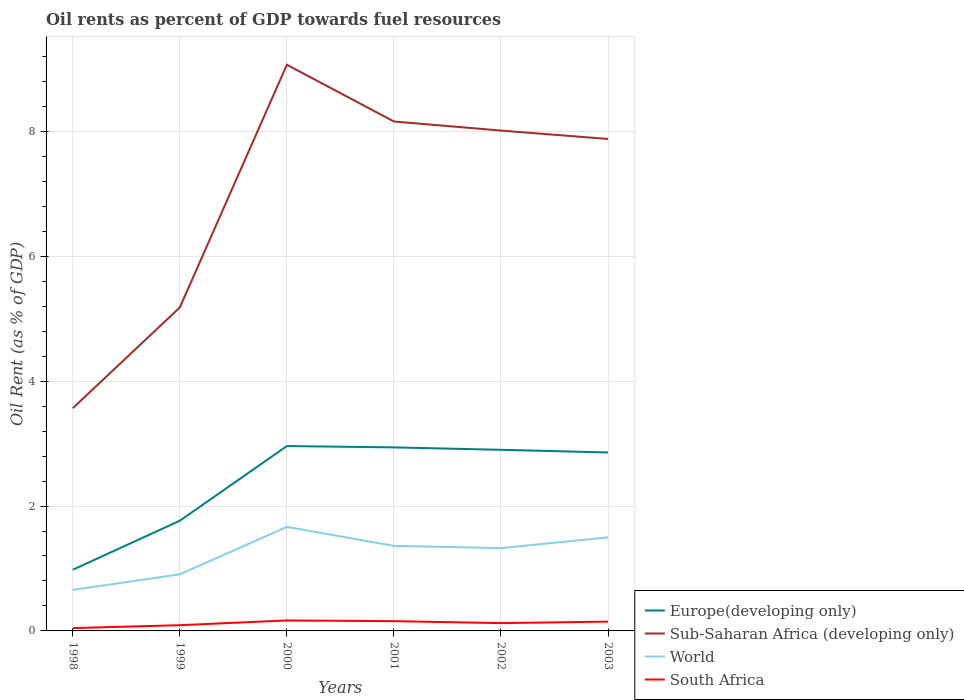Does the line corresponding to South Africa intersect with the line corresponding to World?
Keep it short and to the point. No. Is the number of lines equal to the number of legend labels?
Ensure brevity in your answer.  Yes. Across all years, what is the maximum oil rent in World?
Ensure brevity in your answer.  0.66. What is the total oil rent in South Africa in the graph?
Offer a terse response. 0.04. What is the difference between the highest and the second highest oil rent in Sub-Saharan Africa (developing only)?
Your answer should be very brief. 5.5. What is the difference between the highest and the lowest oil rent in Sub-Saharan Africa (developing only)?
Offer a very short reply. 4. How many lines are there?
Provide a short and direct response. 4. How many years are there in the graph?
Ensure brevity in your answer.  6. What is the difference between two consecutive major ticks on the Y-axis?
Offer a terse response. 2. Does the graph contain any zero values?
Make the answer very short. No. What is the title of the graph?
Give a very brief answer. Oil rents as percent of GDP towards fuel resources. Does "United Kingdom" appear as one of the legend labels in the graph?
Offer a terse response. No. What is the label or title of the X-axis?
Keep it short and to the point. Years. What is the label or title of the Y-axis?
Provide a succinct answer. Oil Rent (as % of GDP). What is the Oil Rent (as % of GDP) in Europe(developing only) in 1998?
Ensure brevity in your answer.  0.98. What is the Oil Rent (as % of GDP) in Sub-Saharan Africa (developing only) in 1998?
Provide a short and direct response. 3.57. What is the Oil Rent (as % of GDP) of World in 1998?
Keep it short and to the point. 0.66. What is the Oil Rent (as % of GDP) of South Africa in 1998?
Make the answer very short. 0.05. What is the Oil Rent (as % of GDP) in Europe(developing only) in 1999?
Your response must be concise. 1.77. What is the Oil Rent (as % of GDP) in Sub-Saharan Africa (developing only) in 1999?
Keep it short and to the point. 5.18. What is the Oil Rent (as % of GDP) in World in 1999?
Your response must be concise. 0.91. What is the Oil Rent (as % of GDP) in South Africa in 1999?
Offer a very short reply. 0.09. What is the Oil Rent (as % of GDP) of Europe(developing only) in 2000?
Your answer should be compact. 2.96. What is the Oil Rent (as % of GDP) of Sub-Saharan Africa (developing only) in 2000?
Make the answer very short. 9.07. What is the Oil Rent (as % of GDP) in World in 2000?
Offer a very short reply. 1.67. What is the Oil Rent (as % of GDP) of South Africa in 2000?
Provide a short and direct response. 0.17. What is the Oil Rent (as % of GDP) in Europe(developing only) in 2001?
Ensure brevity in your answer.  2.94. What is the Oil Rent (as % of GDP) of Sub-Saharan Africa (developing only) in 2001?
Give a very brief answer. 8.16. What is the Oil Rent (as % of GDP) in World in 2001?
Provide a short and direct response. 1.36. What is the Oil Rent (as % of GDP) of South Africa in 2001?
Provide a succinct answer. 0.16. What is the Oil Rent (as % of GDP) in Europe(developing only) in 2002?
Provide a short and direct response. 2.9. What is the Oil Rent (as % of GDP) of Sub-Saharan Africa (developing only) in 2002?
Give a very brief answer. 8.01. What is the Oil Rent (as % of GDP) in World in 2002?
Your response must be concise. 1.33. What is the Oil Rent (as % of GDP) of South Africa in 2002?
Your answer should be compact. 0.13. What is the Oil Rent (as % of GDP) of Europe(developing only) in 2003?
Give a very brief answer. 2.86. What is the Oil Rent (as % of GDP) in Sub-Saharan Africa (developing only) in 2003?
Your answer should be very brief. 7.88. What is the Oil Rent (as % of GDP) of World in 2003?
Offer a very short reply. 1.5. What is the Oil Rent (as % of GDP) in South Africa in 2003?
Keep it short and to the point. 0.15. Across all years, what is the maximum Oil Rent (as % of GDP) of Europe(developing only)?
Your response must be concise. 2.96. Across all years, what is the maximum Oil Rent (as % of GDP) in Sub-Saharan Africa (developing only)?
Your response must be concise. 9.07. Across all years, what is the maximum Oil Rent (as % of GDP) in World?
Your answer should be very brief. 1.67. Across all years, what is the maximum Oil Rent (as % of GDP) of South Africa?
Provide a succinct answer. 0.17. Across all years, what is the minimum Oil Rent (as % of GDP) in Europe(developing only)?
Your response must be concise. 0.98. Across all years, what is the minimum Oil Rent (as % of GDP) of Sub-Saharan Africa (developing only)?
Offer a terse response. 3.57. Across all years, what is the minimum Oil Rent (as % of GDP) of World?
Keep it short and to the point. 0.66. Across all years, what is the minimum Oil Rent (as % of GDP) of South Africa?
Your answer should be compact. 0.05. What is the total Oil Rent (as % of GDP) of Europe(developing only) in the graph?
Give a very brief answer. 14.4. What is the total Oil Rent (as % of GDP) of Sub-Saharan Africa (developing only) in the graph?
Ensure brevity in your answer.  41.86. What is the total Oil Rent (as % of GDP) in World in the graph?
Provide a short and direct response. 7.42. What is the total Oil Rent (as % of GDP) in South Africa in the graph?
Provide a short and direct response. 0.74. What is the difference between the Oil Rent (as % of GDP) of Europe(developing only) in 1998 and that in 1999?
Offer a terse response. -0.79. What is the difference between the Oil Rent (as % of GDP) in Sub-Saharan Africa (developing only) in 1998 and that in 1999?
Offer a very short reply. -1.61. What is the difference between the Oil Rent (as % of GDP) of World in 1998 and that in 1999?
Make the answer very short. -0.25. What is the difference between the Oil Rent (as % of GDP) of South Africa in 1998 and that in 1999?
Make the answer very short. -0.05. What is the difference between the Oil Rent (as % of GDP) of Europe(developing only) in 1998 and that in 2000?
Your answer should be compact. -1.98. What is the difference between the Oil Rent (as % of GDP) of Sub-Saharan Africa (developing only) in 1998 and that in 2000?
Your answer should be very brief. -5.5. What is the difference between the Oil Rent (as % of GDP) of World in 1998 and that in 2000?
Your answer should be very brief. -1.01. What is the difference between the Oil Rent (as % of GDP) in South Africa in 1998 and that in 2000?
Offer a very short reply. -0.12. What is the difference between the Oil Rent (as % of GDP) of Europe(developing only) in 1998 and that in 2001?
Your response must be concise. -1.96. What is the difference between the Oil Rent (as % of GDP) in Sub-Saharan Africa (developing only) in 1998 and that in 2001?
Your response must be concise. -4.59. What is the difference between the Oil Rent (as % of GDP) of World in 1998 and that in 2001?
Your response must be concise. -0.71. What is the difference between the Oil Rent (as % of GDP) in South Africa in 1998 and that in 2001?
Provide a short and direct response. -0.11. What is the difference between the Oil Rent (as % of GDP) of Europe(developing only) in 1998 and that in 2002?
Provide a short and direct response. -1.92. What is the difference between the Oil Rent (as % of GDP) of Sub-Saharan Africa (developing only) in 1998 and that in 2002?
Your response must be concise. -4.45. What is the difference between the Oil Rent (as % of GDP) in World in 1998 and that in 2002?
Make the answer very short. -0.67. What is the difference between the Oil Rent (as % of GDP) in South Africa in 1998 and that in 2002?
Make the answer very short. -0.08. What is the difference between the Oil Rent (as % of GDP) of Europe(developing only) in 1998 and that in 2003?
Your answer should be very brief. -1.88. What is the difference between the Oil Rent (as % of GDP) in Sub-Saharan Africa (developing only) in 1998 and that in 2003?
Your answer should be very brief. -4.31. What is the difference between the Oil Rent (as % of GDP) in World in 1998 and that in 2003?
Give a very brief answer. -0.84. What is the difference between the Oil Rent (as % of GDP) in South Africa in 1998 and that in 2003?
Ensure brevity in your answer.  -0.1. What is the difference between the Oil Rent (as % of GDP) in Europe(developing only) in 1999 and that in 2000?
Provide a succinct answer. -1.2. What is the difference between the Oil Rent (as % of GDP) of Sub-Saharan Africa (developing only) in 1999 and that in 2000?
Provide a short and direct response. -3.89. What is the difference between the Oil Rent (as % of GDP) in World in 1999 and that in 2000?
Keep it short and to the point. -0.76. What is the difference between the Oil Rent (as % of GDP) of South Africa in 1999 and that in 2000?
Ensure brevity in your answer.  -0.08. What is the difference between the Oil Rent (as % of GDP) in Europe(developing only) in 1999 and that in 2001?
Your answer should be compact. -1.17. What is the difference between the Oil Rent (as % of GDP) in Sub-Saharan Africa (developing only) in 1999 and that in 2001?
Your answer should be very brief. -2.98. What is the difference between the Oil Rent (as % of GDP) of World in 1999 and that in 2001?
Make the answer very short. -0.46. What is the difference between the Oil Rent (as % of GDP) of South Africa in 1999 and that in 2001?
Offer a very short reply. -0.06. What is the difference between the Oil Rent (as % of GDP) in Europe(developing only) in 1999 and that in 2002?
Offer a terse response. -1.14. What is the difference between the Oil Rent (as % of GDP) in Sub-Saharan Africa (developing only) in 1999 and that in 2002?
Ensure brevity in your answer.  -2.83. What is the difference between the Oil Rent (as % of GDP) of World in 1999 and that in 2002?
Provide a succinct answer. -0.42. What is the difference between the Oil Rent (as % of GDP) in South Africa in 1999 and that in 2002?
Your answer should be compact. -0.03. What is the difference between the Oil Rent (as % of GDP) in Europe(developing only) in 1999 and that in 2003?
Keep it short and to the point. -1.09. What is the difference between the Oil Rent (as % of GDP) of Sub-Saharan Africa (developing only) in 1999 and that in 2003?
Keep it short and to the point. -2.7. What is the difference between the Oil Rent (as % of GDP) in World in 1999 and that in 2003?
Make the answer very short. -0.59. What is the difference between the Oil Rent (as % of GDP) in South Africa in 1999 and that in 2003?
Offer a terse response. -0.06. What is the difference between the Oil Rent (as % of GDP) in Europe(developing only) in 2000 and that in 2001?
Ensure brevity in your answer.  0.02. What is the difference between the Oil Rent (as % of GDP) of Sub-Saharan Africa (developing only) in 2000 and that in 2001?
Offer a very short reply. 0.91. What is the difference between the Oil Rent (as % of GDP) in World in 2000 and that in 2001?
Provide a short and direct response. 0.3. What is the difference between the Oil Rent (as % of GDP) in South Africa in 2000 and that in 2001?
Offer a very short reply. 0.01. What is the difference between the Oil Rent (as % of GDP) of Europe(developing only) in 2000 and that in 2002?
Give a very brief answer. 0.06. What is the difference between the Oil Rent (as % of GDP) of Sub-Saharan Africa (developing only) in 2000 and that in 2002?
Keep it short and to the point. 1.05. What is the difference between the Oil Rent (as % of GDP) in World in 2000 and that in 2002?
Ensure brevity in your answer.  0.34. What is the difference between the Oil Rent (as % of GDP) in South Africa in 2000 and that in 2002?
Offer a very short reply. 0.04. What is the difference between the Oil Rent (as % of GDP) in Europe(developing only) in 2000 and that in 2003?
Ensure brevity in your answer.  0.1. What is the difference between the Oil Rent (as % of GDP) in Sub-Saharan Africa (developing only) in 2000 and that in 2003?
Ensure brevity in your answer.  1.19. What is the difference between the Oil Rent (as % of GDP) of World in 2000 and that in 2003?
Provide a succinct answer. 0.17. What is the difference between the Oil Rent (as % of GDP) of South Africa in 2000 and that in 2003?
Your answer should be very brief. 0.02. What is the difference between the Oil Rent (as % of GDP) in Europe(developing only) in 2001 and that in 2002?
Offer a very short reply. 0.04. What is the difference between the Oil Rent (as % of GDP) of Sub-Saharan Africa (developing only) in 2001 and that in 2002?
Your answer should be compact. 0.15. What is the difference between the Oil Rent (as % of GDP) in World in 2001 and that in 2002?
Keep it short and to the point. 0.04. What is the difference between the Oil Rent (as % of GDP) of South Africa in 2001 and that in 2002?
Give a very brief answer. 0.03. What is the difference between the Oil Rent (as % of GDP) of Europe(developing only) in 2001 and that in 2003?
Keep it short and to the point. 0.08. What is the difference between the Oil Rent (as % of GDP) in Sub-Saharan Africa (developing only) in 2001 and that in 2003?
Ensure brevity in your answer.  0.28. What is the difference between the Oil Rent (as % of GDP) of World in 2001 and that in 2003?
Offer a terse response. -0.14. What is the difference between the Oil Rent (as % of GDP) in South Africa in 2001 and that in 2003?
Your answer should be very brief. 0.01. What is the difference between the Oil Rent (as % of GDP) in Europe(developing only) in 2002 and that in 2003?
Your answer should be very brief. 0.04. What is the difference between the Oil Rent (as % of GDP) in Sub-Saharan Africa (developing only) in 2002 and that in 2003?
Give a very brief answer. 0.13. What is the difference between the Oil Rent (as % of GDP) in World in 2002 and that in 2003?
Ensure brevity in your answer.  -0.17. What is the difference between the Oil Rent (as % of GDP) in South Africa in 2002 and that in 2003?
Your response must be concise. -0.02. What is the difference between the Oil Rent (as % of GDP) of Europe(developing only) in 1998 and the Oil Rent (as % of GDP) of Sub-Saharan Africa (developing only) in 1999?
Keep it short and to the point. -4.2. What is the difference between the Oil Rent (as % of GDP) in Europe(developing only) in 1998 and the Oil Rent (as % of GDP) in World in 1999?
Keep it short and to the point. 0.07. What is the difference between the Oil Rent (as % of GDP) of Europe(developing only) in 1998 and the Oil Rent (as % of GDP) of South Africa in 1999?
Provide a succinct answer. 0.89. What is the difference between the Oil Rent (as % of GDP) of Sub-Saharan Africa (developing only) in 1998 and the Oil Rent (as % of GDP) of World in 1999?
Make the answer very short. 2.66. What is the difference between the Oil Rent (as % of GDP) in Sub-Saharan Africa (developing only) in 1998 and the Oil Rent (as % of GDP) in South Africa in 1999?
Provide a succinct answer. 3.48. What is the difference between the Oil Rent (as % of GDP) in World in 1998 and the Oil Rent (as % of GDP) in South Africa in 1999?
Ensure brevity in your answer.  0.57. What is the difference between the Oil Rent (as % of GDP) in Europe(developing only) in 1998 and the Oil Rent (as % of GDP) in Sub-Saharan Africa (developing only) in 2000?
Offer a terse response. -8.09. What is the difference between the Oil Rent (as % of GDP) in Europe(developing only) in 1998 and the Oil Rent (as % of GDP) in World in 2000?
Provide a short and direct response. -0.69. What is the difference between the Oil Rent (as % of GDP) in Europe(developing only) in 1998 and the Oil Rent (as % of GDP) in South Africa in 2000?
Make the answer very short. 0.81. What is the difference between the Oil Rent (as % of GDP) in Sub-Saharan Africa (developing only) in 1998 and the Oil Rent (as % of GDP) in World in 2000?
Keep it short and to the point. 1.9. What is the difference between the Oil Rent (as % of GDP) in Sub-Saharan Africa (developing only) in 1998 and the Oil Rent (as % of GDP) in South Africa in 2000?
Provide a succinct answer. 3.4. What is the difference between the Oil Rent (as % of GDP) in World in 1998 and the Oil Rent (as % of GDP) in South Africa in 2000?
Your answer should be very brief. 0.49. What is the difference between the Oil Rent (as % of GDP) of Europe(developing only) in 1998 and the Oil Rent (as % of GDP) of Sub-Saharan Africa (developing only) in 2001?
Keep it short and to the point. -7.18. What is the difference between the Oil Rent (as % of GDP) in Europe(developing only) in 1998 and the Oil Rent (as % of GDP) in World in 2001?
Your response must be concise. -0.38. What is the difference between the Oil Rent (as % of GDP) in Europe(developing only) in 1998 and the Oil Rent (as % of GDP) in South Africa in 2001?
Offer a terse response. 0.82. What is the difference between the Oil Rent (as % of GDP) in Sub-Saharan Africa (developing only) in 1998 and the Oil Rent (as % of GDP) in World in 2001?
Keep it short and to the point. 2.2. What is the difference between the Oil Rent (as % of GDP) of Sub-Saharan Africa (developing only) in 1998 and the Oil Rent (as % of GDP) of South Africa in 2001?
Your response must be concise. 3.41. What is the difference between the Oil Rent (as % of GDP) of World in 1998 and the Oil Rent (as % of GDP) of South Africa in 2001?
Your answer should be very brief. 0.5. What is the difference between the Oil Rent (as % of GDP) of Europe(developing only) in 1998 and the Oil Rent (as % of GDP) of Sub-Saharan Africa (developing only) in 2002?
Ensure brevity in your answer.  -7.03. What is the difference between the Oil Rent (as % of GDP) in Europe(developing only) in 1998 and the Oil Rent (as % of GDP) in World in 2002?
Provide a succinct answer. -0.35. What is the difference between the Oil Rent (as % of GDP) in Europe(developing only) in 1998 and the Oil Rent (as % of GDP) in South Africa in 2002?
Give a very brief answer. 0.85. What is the difference between the Oil Rent (as % of GDP) in Sub-Saharan Africa (developing only) in 1998 and the Oil Rent (as % of GDP) in World in 2002?
Provide a short and direct response. 2.24. What is the difference between the Oil Rent (as % of GDP) in Sub-Saharan Africa (developing only) in 1998 and the Oil Rent (as % of GDP) in South Africa in 2002?
Your response must be concise. 3.44. What is the difference between the Oil Rent (as % of GDP) of World in 1998 and the Oil Rent (as % of GDP) of South Africa in 2002?
Provide a short and direct response. 0.53. What is the difference between the Oil Rent (as % of GDP) of Europe(developing only) in 1998 and the Oil Rent (as % of GDP) of Sub-Saharan Africa (developing only) in 2003?
Give a very brief answer. -6.9. What is the difference between the Oil Rent (as % of GDP) in Europe(developing only) in 1998 and the Oil Rent (as % of GDP) in World in 2003?
Offer a very short reply. -0.52. What is the difference between the Oil Rent (as % of GDP) in Europe(developing only) in 1998 and the Oil Rent (as % of GDP) in South Africa in 2003?
Make the answer very short. 0.83. What is the difference between the Oil Rent (as % of GDP) in Sub-Saharan Africa (developing only) in 1998 and the Oil Rent (as % of GDP) in World in 2003?
Your response must be concise. 2.07. What is the difference between the Oil Rent (as % of GDP) of Sub-Saharan Africa (developing only) in 1998 and the Oil Rent (as % of GDP) of South Africa in 2003?
Offer a terse response. 3.42. What is the difference between the Oil Rent (as % of GDP) of World in 1998 and the Oil Rent (as % of GDP) of South Africa in 2003?
Offer a terse response. 0.51. What is the difference between the Oil Rent (as % of GDP) of Europe(developing only) in 1999 and the Oil Rent (as % of GDP) of Sub-Saharan Africa (developing only) in 2000?
Provide a succinct answer. -7.3. What is the difference between the Oil Rent (as % of GDP) of Europe(developing only) in 1999 and the Oil Rent (as % of GDP) of World in 2000?
Offer a terse response. 0.1. What is the difference between the Oil Rent (as % of GDP) in Europe(developing only) in 1999 and the Oil Rent (as % of GDP) in South Africa in 2000?
Offer a terse response. 1.6. What is the difference between the Oil Rent (as % of GDP) in Sub-Saharan Africa (developing only) in 1999 and the Oil Rent (as % of GDP) in World in 2000?
Your answer should be compact. 3.51. What is the difference between the Oil Rent (as % of GDP) in Sub-Saharan Africa (developing only) in 1999 and the Oil Rent (as % of GDP) in South Africa in 2000?
Make the answer very short. 5.01. What is the difference between the Oil Rent (as % of GDP) of World in 1999 and the Oil Rent (as % of GDP) of South Africa in 2000?
Offer a terse response. 0.74. What is the difference between the Oil Rent (as % of GDP) in Europe(developing only) in 1999 and the Oil Rent (as % of GDP) in Sub-Saharan Africa (developing only) in 2001?
Your response must be concise. -6.39. What is the difference between the Oil Rent (as % of GDP) in Europe(developing only) in 1999 and the Oil Rent (as % of GDP) in World in 2001?
Ensure brevity in your answer.  0.4. What is the difference between the Oil Rent (as % of GDP) of Europe(developing only) in 1999 and the Oil Rent (as % of GDP) of South Africa in 2001?
Your answer should be compact. 1.61. What is the difference between the Oil Rent (as % of GDP) in Sub-Saharan Africa (developing only) in 1999 and the Oil Rent (as % of GDP) in World in 2001?
Provide a succinct answer. 3.82. What is the difference between the Oil Rent (as % of GDP) of Sub-Saharan Africa (developing only) in 1999 and the Oil Rent (as % of GDP) of South Africa in 2001?
Your response must be concise. 5.02. What is the difference between the Oil Rent (as % of GDP) of World in 1999 and the Oil Rent (as % of GDP) of South Africa in 2001?
Your answer should be compact. 0.75. What is the difference between the Oil Rent (as % of GDP) of Europe(developing only) in 1999 and the Oil Rent (as % of GDP) of Sub-Saharan Africa (developing only) in 2002?
Your response must be concise. -6.25. What is the difference between the Oil Rent (as % of GDP) of Europe(developing only) in 1999 and the Oil Rent (as % of GDP) of World in 2002?
Make the answer very short. 0.44. What is the difference between the Oil Rent (as % of GDP) in Europe(developing only) in 1999 and the Oil Rent (as % of GDP) in South Africa in 2002?
Provide a succinct answer. 1.64. What is the difference between the Oil Rent (as % of GDP) of Sub-Saharan Africa (developing only) in 1999 and the Oil Rent (as % of GDP) of World in 2002?
Give a very brief answer. 3.85. What is the difference between the Oil Rent (as % of GDP) in Sub-Saharan Africa (developing only) in 1999 and the Oil Rent (as % of GDP) in South Africa in 2002?
Your answer should be very brief. 5.06. What is the difference between the Oil Rent (as % of GDP) in World in 1999 and the Oil Rent (as % of GDP) in South Africa in 2002?
Provide a succinct answer. 0.78. What is the difference between the Oil Rent (as % of GDP) of Europe(developing only) in 1999 and the Oil Rent (as % of GDP) of Sub-Saharan Africa (developing only) in 2003?
Your answer should be compact. -6.11. What is the difference between the Oil Rent (as % of GDP) in Europe(developing only) in 1999 and the Oil Rent (as % of GDP) in World in 2003?
Your answer should be compact. 0.27. What is the difference between the Oil Rent (as % of GDP) in Europe(developing only) in 1999 and the Oil Rent (as % of GDP) in South Africa in 2003?
Make the answer very short. 1.62. What is the difference between the Oil Rent (as % of GDP) of Sub-Saharan Africa (developing only) in 1999 and the Oil Rent (as % of GDP) of World in 2003?
Offer a terse response. 3.68. What is the difference between the Oil Rent (as % of GDP) of Sub-Saharan Africa (developing only) in 1999 and the Oil Rent (as % of GDP) of South Africa in 2003?
Your answer should be very brief. 5.03. What is the difference between the Oil Rent (as % of GDP) of World in 1999 and the Oil Rent (as % of GDP) of South Africa in 2003?
Provide a succinct answer. 0.76. What is the difference between the Oil Rent (as % of GDP) in Europe(developing only) in 2000 and the Oil Rent (as % of GDP) in Sub-Saharan Africa (developing only) in 2001?
Keep it short and to the point. -5.2. What is the difference between the Oil Rent (as % of GDP) in Europe(developing only) in 2000 and the Oil Rent (as % of GDP) in World in 2001?
Keep it short and to the point. 1.6. What is the difference between the Oil Rent (as % of GDP) of Europe(developing only) in 2000 and the Oil Rent (as % of GDP) of South Africa in 2001?
Offer a very short reply. 2.8. What is the difference between the Oil Rent (as % of GDP) in Sub-Saharan Africa (developing only) in 2000 and the Oil Rent (as % of GDP) in World in 2001?
Offer a terse response. 7.7. What is the difference between the Oil Rent (as % of GDP) of Sub-Saharan Africa (developing only) in 2000 and the Oil Rent (as % of GDP) of South Africa in 2001?
Your answer should be compact. 8.91. What is the difference between the Oil Rent (as % of GDP) in World in 2000 and the Oil Rent (as % of GDP) in South Africa in 2001?
Provide a short and direct response. 1.51. What is the difference between the Oil Rent (as % of GDP) of Europe(developing only) in 2000 and the Oil Rent (as % of GDP) of Sub-Saharan Africa (developing only) in 2002?
Make the answer very short. -5.05. What is the difference between the Oil Rent (as % of GDP) in Europe(developing only) in 2000 and the Oil Rent (as % of GDP) in World in 2002?
Your answer should be very brief. 1.63. What is the difference between the Oil Rent (as % of GDP) of Europe(developing only) in 2000 and the Oil Rent (as % of GDP) of South Africa in 2002?
Make the answer very short. 2.84. What is the difference between the Oil Rent (as % of GDP) of Sub-Saharan Africa (developing only) in 2000 and the Oil Rent (as % of GDP) of World in 2002?
Provide a succinct answer. 7.74. What is the difference between the Oil Rent (as % of GDP) of Sub-Saharan Africa (developing only) in 2000 and the Oil Rent (as % of GDP) of South Africa in 2002?
Keep it short and to the point. 8.94. What is the difference between the Oil Rent (as % of GDP) of World in 2000 and the Oil Rent (as % of GDP) of South Africa in 2002?
Your response must be concise. 1.54. What is the difference between the Oil Rent (as % of GDP) of Europe(developing only) in 2000 and the Oil Rent (as % of GDP) of Sub-Saharan Africa (developing only) in 2003?
Make the answer very short. -4.92. What is the difference between the Oil Rent (as % of GDP) of Europe(developing only) in 2000 and the Oil Rent (as % of GDP) of World in 2003?
Provide a succinct answer. 1.46. What is the difference between the Oil Rent (as % of GDP) in Europe(developing only) in 2000 and the Oil Rent (as % of GDP) in South Africa in 2003?
Your answer should be very brief. 2.81. What is the difference between the Oil Rent (as % of GDP) of Sub-Saharan Africa (developing only) in 2000 and the Oil Rent (as % of GDP) of World in 2003?
Your answer should be very brief. 7.57. What is the difference between the Oil Rent (as % of GDP) in Sub-Saharan Africa (developing only) in 2000 and the Oil Rent (as % of GDP) in South Africa in 2003?
Keep it short and to the point. 8.92. What is the difference between the Oil Rent (as % of GDP) of World in 2000 and the Oil Rent (as % of GDP) of South Africa in 2003?
Make the answer very short. 1.52. What is the difference between the Oil Rent (as % of GDP) of Europe(developing only) in 2001 and the Oil Rent (as % of GDP) of Sub-Saharan Africa (developing only) in 2002?
Provide a succinct answer. -5.07. What is the difference between the Oil Rent (as % of GDP) in Europe(developing only) in 2001 and the Oil Rent (as % of GDP) in World in 2002?
Your answer should be very brief. 1.61. What is the difference between the Oil Rent (as % of GDP) in Europe(developing only) in 2001 and the Oil Rent (as % of GDP) in South Africa in 2002?
Offer a very short reply. 2.81. What is the difference between the Oil Rent (as % of GDP) in Sub-Saharan Africa (developing only) in 2001 and the Oil Rent (as % of GDP) in World in 2002?
Ensure brevity in your answer.  6.83. What is the difference between the Oil Rent (as % of GDP) of Sub-Saharan Africa (developing only) in 2001 and the Oil Rent (as % of GDP) of South Africa in 2002?
Your answer should be compact. 8.03. What is the difference between the Oil Rent (as % of GDP) in World in 2001 and the Oil Rent (as % of GDP) in South Africa in 2002?
Your answer should be very brief. 1.24. What is the difference between the Oil Rent (as % of GDP) in Europe(developing only) in 2001 and the Oil Rent (as % of GDP) in Sub-Saharan Africa (developing only) in 2003?
Your response must be concise. -4.94. What is the difference between the Oil Rent (as % of GDP) in Europe(developing only) in 2001 and the Oil Rent (as % of GDP) in World in 2003?
Offer a terse response. 1.44. What is the difference between the Oil Rent (as % of GDP) of Europe(developing only) in 2001 and the Oil Rent (as % of GDP) of South Africa in 2003?
Your answer should be compact. 2.79. What is the difference between the Oil Rent (as % of GDP) in Sub-Saharan Africa (developing only) in 2001 and the Oil Rent (as % of GDP) in World in 2003?
Make the answer very short. 6.66. What is the difference between the Oil Rent (as % of GDP) of Sub-Saharan Africa (developing only) in 2001 and the Oil Rent (as % of GDP) of South Africa in 2003?
Your response must be concise. 8.01. What is the difference between the Oil Rent (as % of GDP) in World in 2001 and the Oil Rent (as % of GDP) in South Africa in 2003?
Your answer should be very brief. 1.21. What is the difference between the Oil Rent (as % of GDP) of Europe(developing only) in 2002 and the Oil Rent (as % of GDP) of Sub-Saharan Africa (developing only) in 2003?
Provide a short and direct response. -4.98. What is the difference between the Oil Rent (as % of GDP) of Europe(developing only) in 2002 and the Oil Rent (as % of GDP) of World in 2003?
Make the answer very short. 1.4. What is the difference between the Oil Rent (as % of GDP) in Europe(developing only) in 2002 and the Oil Rent (as % of GDP) in South Africa in 2003?
Your answer should be very brief. 2.75. What is the difference between the Oil Rent (as % of GDP) in Sub-Saharan Africa (developing only) in 2002 and the Oil Rent (as % of GDP) in World in 2003?
Provide a short and direct response. 6.51. What is the difference between the Oil Rent (as % of GDP) of Sub-Saharan Africa (developing only) in 2002 and the Oil Rent (as % of GDP) of South Africa in 2003?
Provide a succinct answer. 7.86. What is the difference between the Oil Rent (as % of GDP) in World in 2002 and the Oil Rent (as % of GDP) in South Africa in 2003?
Make the answer very short. 1.18. What is the average Oil Rent (as % of GDP) in Europe(developing only) per year?
Provide a short and direct response. 2.4. What is the average Oil Rent (as % of GDP) in Sub-Saharan Africa (developing only) per year?
Provide a succinct answer. 6.98. What is the average Oil Rent (as % of GDP) of World per year?
Make the answer very short. 1.24. What is the average Oil Rent (as % of GDP) of South Africa per year?
Provide a succinct answer. 0.12. In the year 1998, what is the difference between the Oil Rent (as % of GDP) in Europe(developing only) and Oil Rent (as % of GDP) in Sub-Saharan Africa (developing only)?
Your response must be concise. -2.59. In the year 1998, what is the difference between the Oil Rent (as % of GDP) of Europe(developing only) and Oil Rent (as % of GDP) of World?
Ensure brevity in your answer.  0.32. In the year 1998, what is the difference between the Oil Rent (as % of GDP) in Europe(developing only) and Oil Rent (as % of GDP) in South Africa?
Your answer should be compact. 0.93. In the year 1998, what is the difference between the Oil Rent (as % of GDP) of Sub-Saharan Africa (developing only) and Oil Rent (as % of GDP) of World?
Keep it short and to the point. 2.91. In the year 1998, what is the difference between the Oil Rent (as % of GDP) of Sub-Saharan Africa (developing only) and Oil Rent (as % of GDP) of South Africa?
Your answer should be compact. 3.52. In the year 1998, what is the difference between the Oil Rent (as % of GDP) of World and Oil Rent (as % of GDP) of South Africa?
Make the answer very short. 0.61. In the year 1999, what is the difference between the Oil Rent (as % of GDP) in Europe(developing only) and Oil Rent (as % of GDP) in Sub-Saharan Africa (developing only)?
Provide a short and direct response. -3.42. In the year 1999, what is the difference between the Oil Rent (as % of GDP) in Europe(developing only) and Oil Rent (as % of GDP) in World?
Give a very brief answer. 0.86. In the year 1999, what is the difference between the Oil Rent (as % of GDP) in Europe(developing only) and Oil Rent (as % of GDP) in South Africa?
Give a very brief answer. 1.67. In the year 1999, what is the difference between the Oil Rent (as % of GDP) in Sub-Saharan Africa (developing only) and Oil Rent (as % of GDP) in World?
Your answer should be compact. 4.27. In the year 1999, what is the difference between the Oil Rent (as % of GDP) in Sub-Saharan Africa (developing only) and Oil Rent (as % of GDP) in South Africa?
Provide a succinct answer. 5.09. In the year 1999, what is the difference between the Oil Rent (as % of GDP) in World and Oil Rent (as % of GDP) in South Africa?
Give a very brief answer. 0.81. In the year 2000, what is the difference between the Oil Rent (as % of GDP) of Europe(developing only) and Oil Rent (as % of GDP) of Sub-Saharan Africa (developing only)?
Give a very brief answer. -6.11. In the year 2000, what is the difference between the Oil Rent (as % of GDP) of Europe(developing only) and Oil Rent (as % of GDP) of World?
Provide a short and direct response. 1.29. In the year 2000, what is the difference between the Oil Rent (as % of GDP) of Europe(developing only) and Oil Rent (as % of GDP) of South Africa?
Your response must be concise. 2.79. In the year 2000, what is the difference between the Oil Rent (as % of GDP) in Sub-Saharan Africa (developing only) and Oil Rent (as % of GDP) in World?
Your answer should be compact. 7.4. In the year 2000, what is the difference between the Oil Rent (as % of GDP) in Sub-Saharan Africa (developing only) and Oil Rent (as % of GDP) in South Africa?
Offer a terse response. 8.9. In the year 2000, what is the difference between the Oil Rent (as % of GDP) in World and Oil Rent (as % of GDP) in South Africa?
Make the answer very short. 1.5. In the year 2001, what is the difference between the Oil Rent (as % of GDP) of Europe(developing only) and Oil Rent (as % of GDP) of Sub-Saharan Africa (developing only)?
Make the answer very short. -5.22. In the year 2001, what is the difference between the Oil Rent (as % of GDP) of Europe(developing only) and Oil Rent (as % of GDP) of World?
Your response must be concise. 1.58. In the year 2001, what is the difference between the Oil Rent (as % of GDP) of Europe(developing only) and Oil Rent (as % of GDP) of South Africa?
Provide a succinct answer. 2.78. In the year 2001, what is the difference between the Oil Rent (as % of GDP) of Sub-Saharan Africa (developing only) and Oil Rent (as % of GDP) of World?
Your answer should be compact. 6.8. In the year 2001, what is the difference between the Oil Rent (as % of GDP) in Sub-Saharan Africa (developing only) and Oil Rent (as % of GDP) in South Africa?
Provide a short and direct response. 8. In the year 2001, what is the difference between the Oil Rent (as % of GDP) of World and Oil Rent (as % of GDP) of South Africa?
Offer a terse response. 1.21. In the year 2002, what is the difference between the Oil Rent (as % of GDP) in Europe(developing only) and Oil Rent (as % of GDP) in Sub-Saharan Africa (developing only)?
Keep it short and to the point. -5.11. In the year 2002, what is the difference between the Oil Rent (as % of GDP) in Europe(developing only) and Oil Rent (as % of GDP) in World?
Offer a very short reply. 1.57. In the year 2002, what is the difference between the Oil Rent (as % of GDP) in Europe(developing only) and Oil Rent (as % of GDP) in South Africa?
Provide a succinct answer. 2.78. In the year 2002, what is the difference between the Oil Rent (as % of GDP) in Sub-Saharan Africa (developing only) and Oil Rent (as % of GDP) in World?
Provide a succinct answer. 6.69. In the year 2002, what is the difference between the Oil Rent (as % of GDP) of Sub-Saharan Africa (developing only) and Oil Rent (as % of GDP) of South Africa?
Ensure brevity in your answer.  7.89. In the year 2002, what is the difference between the Oil Rent (as % of GDP) of World and Oil Rent (as % of GDP) of South Africa?
Your answer should be compact. 1.2. In the year 2003, what is the difference between the Oil Rent (as % of GDP) in Europe(developing only) and Oil Rent (as % of GDP) in Sub-Saharan Africa (developing only)?
Ensure brevity in your answer.  -5.02. In the year 2003, what is the difference between the Oil Rent (as % of GDP) of Europe(developing only) and Oil Rent (as % of GDP) of World?
Provide a succinct answer. 1.36. In the year 2003, what is the difference between the Oil Rent (as % of GDP) in Europe(developing only) and Oil Rent (as % of GDP) in South Africa?
Provide a short and direct response. 2.71. In the year 2003, what is the difference between the Oil Rent (as % of GDP) of Sub-Saharan Africa (developing only) and Oil Rent (as % of GDP) of World?
Your response must be concise. 6.38. In the year 2003, what is the difference between the Oil Rent (as % of GDP) in Sub-Saharan Africa (developing only) and Oil Rent (as % of GDP) in South Africa?
Ensure brevity in your answer.  7.73. In the year 2003, what is the difference between the Oil Rent (as % of GDP) of World and Oil Rent (as % of GDP) of South Africa?
Offer a terse response. 1.35. What is the ratio of the Oil Rent (as % of GDP) of Europe(developing only) in 1998 to that in 1999?
Your answer should be compact. 0.56. What is the ratio of the Oil Rent (as % of GDP) in Sub-Saharan Africa (developing only) in 1998 to that in 1999?
Provide a short and direct response. 0.69. What is the ratio of the Oil Rent (as % of GDP) in World in 1998 to that in 1999?
Your answer should be compact. 0.72. What is the ratio of the Oil Rent (as % of GDP) of South Africa in 1998 to that in 1999?
Keep it short and to the point. 0.49. What is the ratio of the Oil Rent (as % of GDP) in Europe(developing only) in 1998 to that in 2000?
Offer a terse response. 0.33. What is the ratio of the Oil Rent (as % of GDP) in Sub-Saharan Africa (developing only) in 1998 to that in 2000?
Make the answer very short. 0.39. What is the ratio of the Oil Rent (as % of GDP) of World in 1998 to that in 2000?
Your answer should be very brief. 0.39. What is the ratio of the Oil Rent (as % of GDP) of South Africa in 1998 to that in 2000?
Provide a succinct answer. 0.27. What is the ratio of the Oil Rent (as % of GDP) of Europe(developing only) in 1998 to that in 2001?
Your response must be concise. 0.33. What is the ratio of the Oil Rent (as % of GDP) of Sub-Saharan Africa (developing only) in 1998 to that in 2001?
Provide a short and direct response. 0.44. What is the ratio of the Oil Rent (as % of GDP) in World in 1998 to that in 2001?
Keep it short and to the point. 0.48. What is the ratio of the Oil Rent (as % of GDP) in South Africa in 1998 to that in 2001?
Your answer should be very brief. 0.29. What is the ratio of the Oil Rent (as % of GDP) of Europe(developing only) in 1998 to that in 2002?
Give a very brief answer. 0.34. What is the ratio of the Oil Rent (as % of GDP) in Sub-Saharan Africa (developing only) in 1998 to that in 2002?
Keep it short and to the point. 0.45. What is the ratio of the Oil Rent (as % of GDP) of World in 1998 to that in 2002?
Your answer should be very brief. 0.5. What is the ratio of the Oil Rent (as % of GDP) of South Africa in 1998 to that in 2002?
Make the answer very short. 0.36. What is the ratio of the Oil Rent (as % of GDP) of Europe(developing only) in 1998 to that in 2003?
Offer a terse response. 0.34. What is the ratio of the Oil Rent (as % of GDP) in Sub-Saharan Africa (developing only) in 1998 to that in 2003?
Your answer should be compact. 0.45. What is the ratio of the Oil Rent (as % of GDP) in World in 1998 to that in 2003?
Give a very brief answer. 0.44. What is the ratio of the Oil Rent (as % of GDP) of South Africa in 1998 to that in 2003?
Your response must be concise. 0.3. What is the ratio of the Oil Rent (as % of GDP) of Europe(developing only) in 1999 to that in 2000?
Give a very brief answer. 0.6. What is the ratio of the Oil Rent (as % of GDP) in World in 1999 to that in 2000?
Your answer should be compact. 0.54. What is the ratio of the Oil Rent (as % of GDP) of South Africa in 1999 to that in 2000?
Provide a short and direct response. 0.55. What is the ratio of the Oil Rent (as % of GDP) in Europe(developing only) in 1999 to that in 2001?
Make the answer very short. 0.6. What is the ratio of the Oil Rent (as % of GDP) in Sub-Saharan Africa (developing only) in 1999 to that in 2001?
Make the answer very short. 0.64. What is the ratio of the Oil Rent (as % of GDP) of World in 1999 to that in 2001?
Give a very brief answer. 0.67. What is the ratio of the Oil Rent (as % of GDP) of South Africa in 1999 to that in 2001?
Your answer should be compact. 0.59. What is the ratio of the Oil Rent (as % of GDP) of Europe(developing only) in 1999 to that in 2002?
Make the answer very short. 0.61. What is the ratio of the Oil Rent (as % of GDP) of Sub-Saharan Africa (developing only) in 1999 to that in 2002?
Your answer should be compact. 0.65. What is the ratio of the Oil Rent (as % of GDP) in World in 1999 to that in 2002?
Give a very brief answer. 0.68. What is the ratio of the Oil Rent (as % of GDP) in South Africa in 1999 to that in 2002?
Ensure brevity in your answer.  0.73. What is the ratio of the Oil Rent (as % of GDP) in Europe(developing only) in 1999 to that in 2003?
Provide a succinct answer. 0.62. What is the ratio of the Oil Rent (as % of GDP) in Sub-Saharan Africa (developing only) in 1999 to that in 2003?
Give a very brief answer. 0.66. What is the ratio of the Oil Rent (as % of GDP) in World in 1999 to that in 2003?
Your answer should be very brief. 0.6. What is the ratio of the Oil Rent (as % of GDP) of South Africa in 1999 to that in 2003?
Keep it short and to the point. 0.62. What is the ratio of the Oil Rent (as % of GDP) in Europe(developing only) in 2000 to that in 2001?
Provide a succinct answer. 1.01. What is the ratio of the Oil Rent (as % of GDP) in Sub-Saharan Africa (developing only) in 2000 to that in 2001?
Keep it short and to the point. 1.11. What is the ratio of the Oil Rent (as % of GDP) in World in 2000 to that in 2001?
Provide a short and direct response. 1.22. What is the ratio of the Oil Rent (as % of GDP) of South Africa in 2000 to that in 2001?
Provide a short and direct response. 1.07. What is the ratio of the Oil Rent (as % of GDP) in Europe(developing only) in 2000 to that in 2002?
Ensure brevity in your answer.  1.02. What is the ratio of the Oil Rent (as % of GDP) in Sub-Saharan Africa (developing only) in 2000 to that in 2002?
Offer a terse response. 1.13. What is the ratio of the Oil Rent (as % of GDP) of World in 2000 to that in 2002?
Ensure brevity in your answer.  1.26. What is the ratio of the Oil Rent (as % of GDP) of South Africa in 2000 to that in 2002?
Offer a terse response. 1.34. What is the ratio of the Oil Rent (as % of GDP) in Europe(developing only) in 2000 to that in 2003?
Make the answer very short. 1.04. What is the ratio of the Oil Rent (as % of GDP) of Sub-Saharan Africa (developing only) in 2000 to that in 2003?
Offer a very short reply. 1.15. What is the ratio of the Oil Rent (as % of GDP) of World in 2000 to that in 2003?
Offer a very short reply. 1.11. What is the ratio of the Oil Rent (as % of GDP) of South Africa in 2000 to that in 2003?
Offer a very short reply. 1.13. What is the ratio of the Oil Rent (as % of GDP) of Europe(developing only) in 2001 to that in 2002?
Ensure brevity in your answer.  1.01. What is the ratio of the Oil Rent (as % of GDP) in Sub-Saharan Africa (developing only) in 2001 to that in 2002?
Your response must be concise. 1.02. What is the ratio of the Oil Rent (as % of GDP) of World in 2001 to that in 2002?
Provide a short and direct response. 1.03. What is the ratio of the Oil Rent (as % of GDP) in South Africa in 2001 to that in 2002?
Keep it short and to the point. 1.25. What is the ratio of the Oil Rent (as % of GDP) in Europe(developing only) in 2001 to that in 2003?
Make the answer very short. 1.03. What is the ratio of the Oil Rent (as % of GDP) in Sub-Saharan Africa (developing only) in 2001 to that in 2003?
Provide a succinct answer. 1.04. What is the ratio of the Oil Rent (as % of GDP) of World in 2001 to that in 2003?
Provide a short and direct response. 0.91. What is the ratio of the Oil Rent (as % of GDP) of South Africa in 2001 to that in 2003?
Keep it short and to the point. 1.05. What is the ratio of the Oil Rent (as % of GDP) in Europe(developing only) in 2002 to that in 2003?
Make the answer very short. 1.01. What is the ratio of the Oil Rent (as % of GDP) in Sub-Saharan Africa (developing only) in 2002 to that in 2003?
Provide a short and direct response. 1.02. What is the ratio of the Oil Rent (as % of GDP) of World in 2002 to that in 2003?
Offer a terse response. 0.88. What is the ratio of the Oil Rent (as % of GDP) of South Africa in 2002 to that in 2003?
Your response must be concise. 0.84. What is the difference between the highest and the second highest Oil Rent (as % of GDP) of Europe(developing only)?
Ensure brevity in your answer.  0.02. What is the difference between the highest and the second highest Oil Rent (as % of GDP) of Sub-Saharan Africa (developing only)?
Make the answer very short. 0.91. What is the difference between the highest and the second highest Oil Rent (as % of GDP) in World?
Offer a terse response. 0.17. What is the difference between the highest and the second highest Oil Rent (as % of GDP) in South Africa?
Offer a terse response. 0.01. What is the difference between the highest and the lowest Oil Rent (as % of GDP) in Europe(developing only)?
Provide a short and direct response. 1.98. What is the difference between the highest and the lowest Oil Rent (as % of GDP) of Sub-Saharan Africa (developing only)?
Make the answer very short. 5.5. What is the difference between the highest and the lowest Oil Rent (as % of GDP) in World?
Your answer should be very brief. 1.01. What is the difference between the highest and the lowest Oil Rent (as % of GDP) of South Africa?
Your response must be concise. 0.12. 